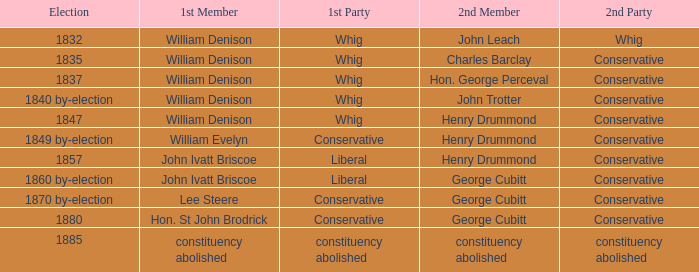In the 1832 election, which party has william denison as its first member? Whig. 